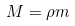Convert formula to latex. <formula><loc_0><loc_0><loc_500><loc_500>M = \rho m</formula> 